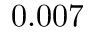Convert formula to latex. <formula><loc_0><loc_0><loc_500><loc_500>0 . 0 0 7</formula> 